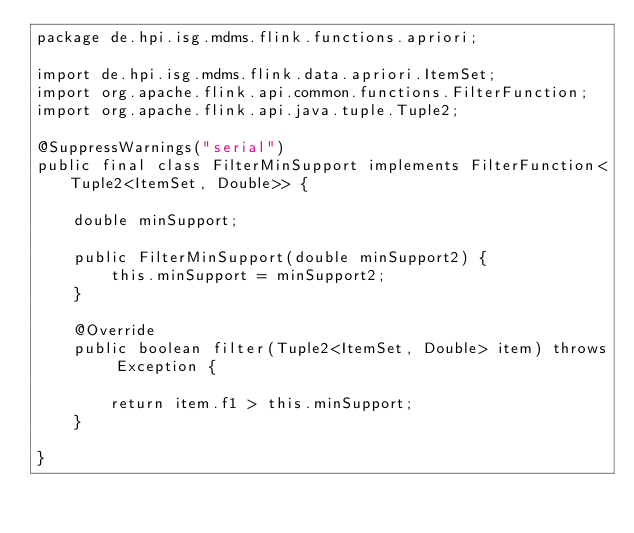Convert code to text. <code><loc_0><loc_0><loc_500><loc_500><_Java_>package de.hpi.isg.mdms.flink.functions.apriori;

import de.hpi.isg.mdms.flink.data.apriori.ItemSet;
import org.apache.flink.api.common.functions.FilterFunction;
import org.apache.flink.api.java.tuple.Tuple2;

@SuppressWarnings("serial")
public final class FilterMinSupport implements FilterFunction<Tuple2<ItemSet, Double>> {

    double minSupport;

    public FilterMinSupport(double minSupport2) {
        this.minSupport = minSupport2;
    }

    @Override
    public boolean filter(Tuple2<ItemSet, Double> item) throws Exception {

        return item.f1 > this.minSupport;
    }

}
</code> 